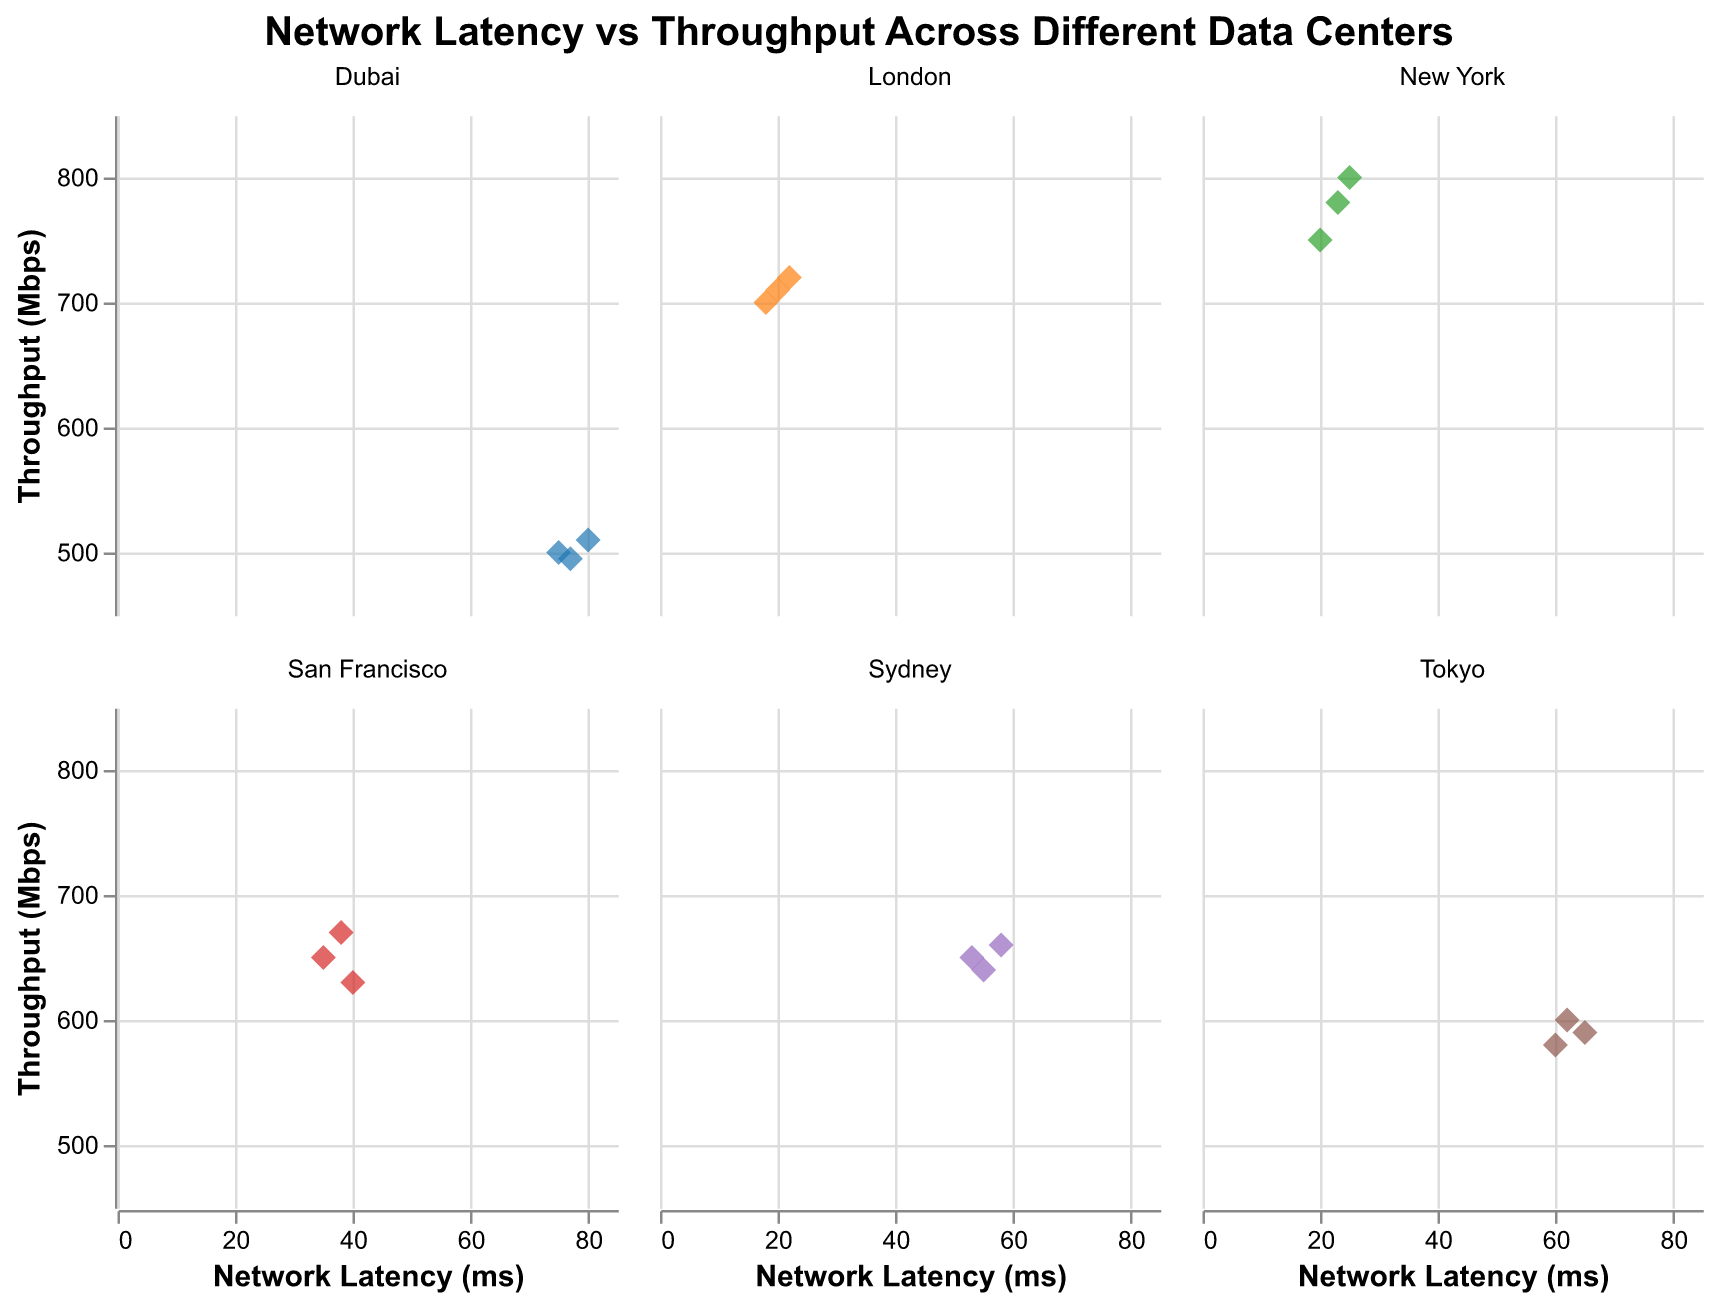Which data center has the highest average throughput? Compute the average throughput for each data center: New York (777 Mbps), San Francisco (650 Mbps), London (710 Mbps), Tokyo (590 Mbps), Sydney (650 Mbps), Dubai (502 Mbps). New York has the highest average throughput.
Answer: New York Which data center has the highest latency point? Identify the highest network latency value among all points: Dubai has the highest latency point at 80 ms.
Answer: Dubai What is the range of throughputs in the London data center? The London data center has throughput values of 700, 720, and 710 Mbps. The range is 720 - 700 = 20 Mbps.
Answer: 20 Mbps Which data center has the lowest minimum network latency? Identify the lowest network latency value in each data center: New York (20 ms), San Francisco (35 ms), London (18 ms), Tokyo (60 ms), Sydney (53 ms), Dubai (75 ms). London has the lowest minimum network latency.
Answer: London What is the average network latency for the Tokyo data center? Compute the average latency for each value in the Tokyo data center (60, 65, 62 ms). The sum is 187, and the average is 187 / 3 ≈ 62.33 ms.
Answer: 62.33 ms How does throughput in Sydney compare to that in Tokyo? Compute the average throughput for both data centers: Sydney (650 Mbps) and Tokyo (590 Mbps). Sydney has a higher average throughput than Tokyo.
Answer: Sydney has higher throughput Which data center has the most data points in the plot? Count the number of data points for each data center. Each data center has 3 data points, so there is no single data center with the most data points.
Answer: All equal Is there a general trend between network latency and throughput? Visually inspect the scatter plots; generally, as network latency increases, throughput decreases, indicating a negative correlation.
Answer: Negative correlation 